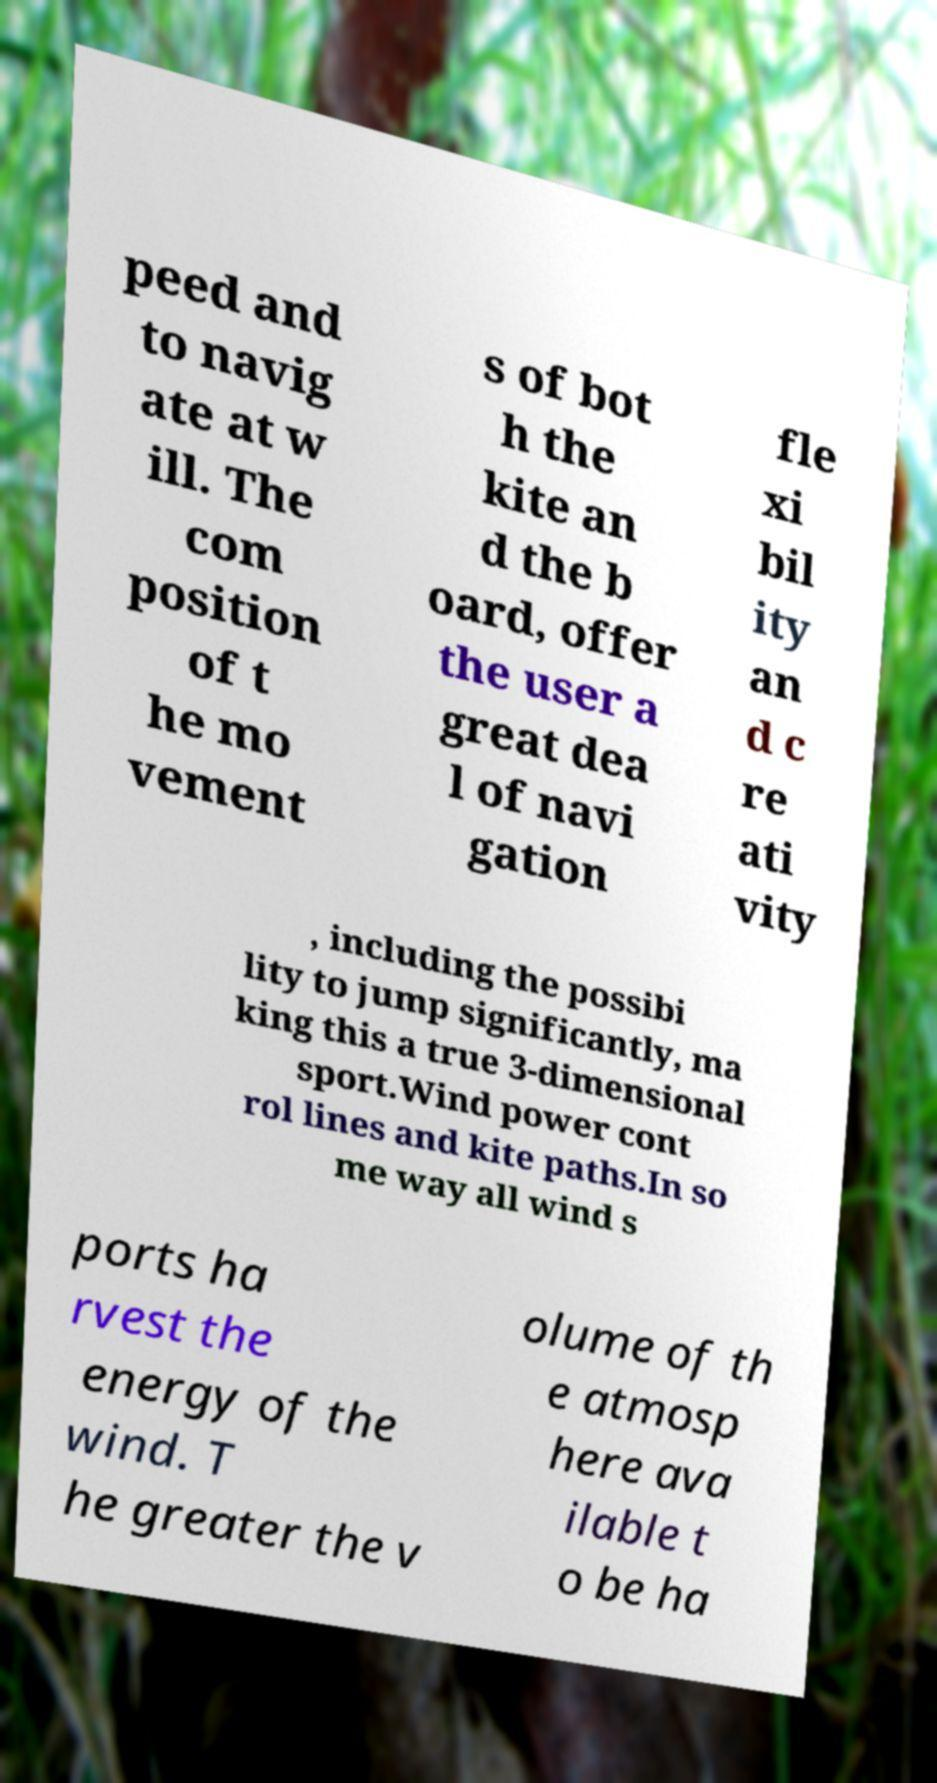I need the written content from this picture converted into text. Can you do that? peed and to navig ate at w ill. The com position of t he mo vement s of bot h the kite an d the b oard, offer the user a great dea l of navi gation fle xi bil ity an d c re ati vity , including the possibi lity to jump significantly, ma king this a true 3-dimensional sport.Wind power cont rol lines and kite paths.In so me way all wind s ports ha rvest the energy of the wind. T he greater the v olume of th e atmosp here ava ilable t o be ha 